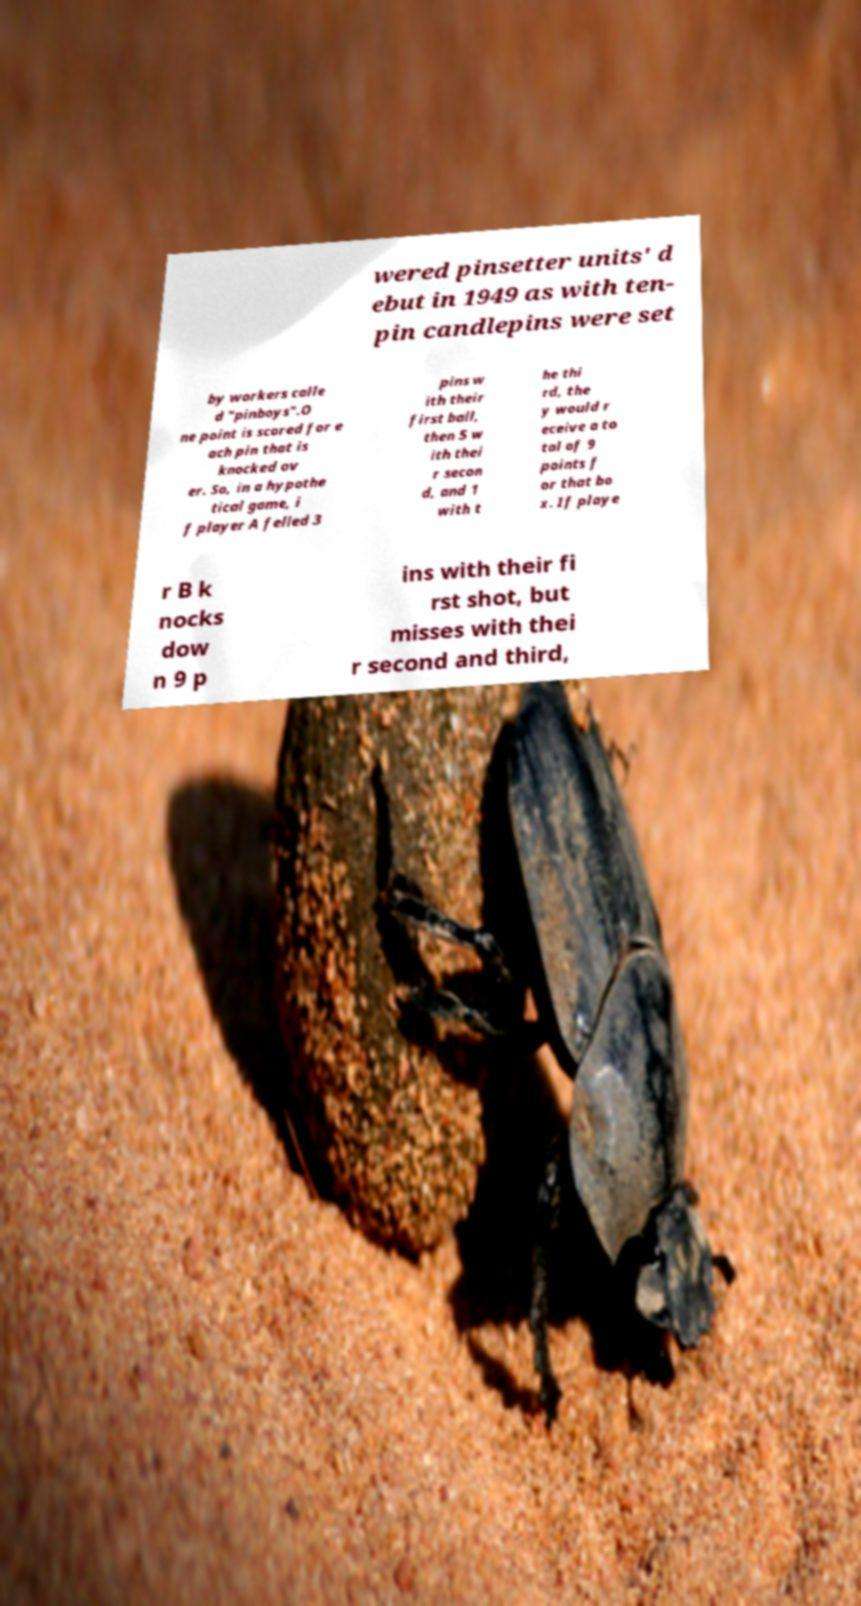Please identify and transcribe the text found in this image. wered pinsetter units' d ebut in 1949 as with ten- pin candlepins were set by workers calle d "pinboys".O ne point is scored for e ach pin that is knocked ov er. So, in a hypothe tical game, i f player A felled 3 pins w ith their first ball, then 5 w ith thei r secon d, and 1 with t he thi rd, the y would r eceive a to tal of 9 points f or that bo x. If playe r B k nocks dow n 9 p ins with their fi rst shot, but misses with thei r second and third, 